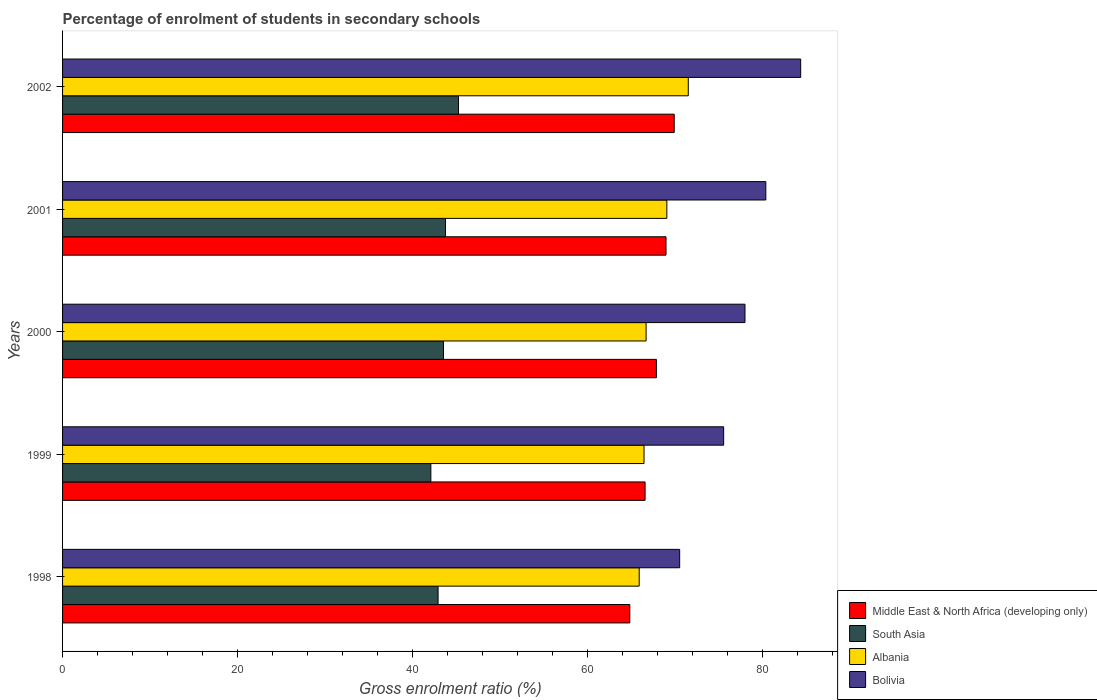How many different coloured bars are there?
Keep it short and to the point. 4. Are the number of bars on each tick of the Y-axis equal?
Provide a short and direct response. Yes. How many bars are there on the 5th tick from the bottom?
Provide a succinct answer. 4. What is the label of the 4th group of bars from the top?
Your answer should be compact. 1999. What is the percentage of students enrolled in secondary schools in South Asia in 2000?
Offer a terse response. 43.53. Across all years, what is the maximum percentage of students enrolled in secondary schools in Bolivia?
Keep it short and to the point. 84.34. Across all years, what is the minimum percentage of students enrolled in secondary schools in South Asia?
Offer a terse response. 42.09. In which year was the percentage of students enrolled in secondary schools in Albania maximum?
Your answer should be very brief. 2002. What is the total percentage of students enrolled in secondary schools in Bolivia in the graph?
Offer a very short reply. 388.74. What is the difference between the percentage of students enrolled in secondary schools in Albania in 2000 and that in 2001?
Your response must be concise. -2.37. What is the difference between the percentage of students enrolled in secondary schools in Bolivia in 2000 and the percentage of students enrolled in secondary schools in Middle East & North Africa (developing only) in 1999?
Give a very brief answer. 11.42. What is the average percentage of students enrolled in secondary schools in Albania per year?
Offer a terse response. 67.91. In the year 2002, what is the difference between the percentage of students enrolled in secondary schools in South Asia and percentage of students enrolled in secondary schools in Middle East & North Africa (developing only)?
Keep it short and to the point. -24.65. What is the ratio of the percentage of students enrolled in secondary schools in Bolivia in 1999 to that in 2001?
Ensure brevity in your answer.  0.94. Is the percentage of students enrolled in secondary schools in Middle East & North Africa (developing only) in 1998 less than that in 1999?
Offer a terse response. Yes. What is the difference between the highest and the second highest percentage of students enrolled in secondary schools in Middle East & North Africa (developing only)?
Provide a short and direct response. 0.94. What is the difference between the highest and the lowest percentage of students enrolled in secondary schools in Middle East & North Africa (developing only)?
Make the answer very short. 5.07. Is it the case that in every year, the sum of the percentage of students enrolled in secondary schools in Middle East & North Africa (developing only) and percentage of students enrolled in secondary schools in Bolivia is greater than the sum of percentage of students enrolled in secondary schools in Albania and percentage of students enrolled in secondary schools in South Asia?
Provide a short and direct response. Yes. What does the 3rd bar from the top in 2000 represents?
Provide a short and direct response. South Asia. What does the 1st bar from the bottom in 2001 represents?
Offer a very short reply. Middle East & North Africa (developing only). How many bars are there?
Give a very brief answer. 20. Are all the bars in the graph horizontal?
Your response must be concise. Yes. What is the difference between two consecutive major ticks on the X-axis?
Offer a very short reply. 20. Does the graph contain any zero values?
Your response must be concise. No. Does the graph contain grids?
Offer a very short reply. No. How many legend labels are there?
Your response must be concise. 4. How are the legend labels stacked?
Provide a succinct answer. Vertical. What is the title of the graph?
Your answer should be compact. Percentage of enrolment of students in secondary schools. Does "Djibouti" appear as one of the legend labels in the graph?
Make the answer very short. No. What is the label or title of the X-axis?
Your answer should be very brief. Gross enrolment ratio (%). What is the label or title of the Y-axis?
Provide a short and direct response. Years. What is the Gross enrolment ratio (%) in Middle East & North Africa (developing only) in 1998?
Your answer should be very brief. 64.82. What is the Gross enrolment ratio (%) in South Asia in 1998?
Your response must be concise. 42.91. What is the Gross enrolment ratio (%) of Albania in 1998?
Ensure brevity in your answer.  65.89. What is the Gross enrolment ratio (%) in Bolivia in 1998?
Ensure brevity in your answer.  70.51. What is the Gross enrolment ratio (%) of Middle East & North Africa (developing only) in 1999?
Offer a terse response. 66.56. What is the Gross enrolment ratio (%) in South Asia in 1999?
Keep it short and to the point. 42.09. What is the Gross enrolment ratio (%) in Albania in 1999?
Provide a short and direct response. 66.44. What is the Gross enrolment ratio (%) in Bolivia in 1999?
Give a very brief answer. 75.54. What is the Gross enrolment ratio (%) in Middle East & North Africa (developing only) in 2000?
Keep it short and to the point. 67.86. What is the Gross enrolment ratio (%) of South Asia in 2000?
Give a very brief answer. 43.53. What is the Gross enrolment ratio (%) in Albania in 2000?
Give a very brief answer. 66.68. What is the Gross enrolment ratio (%) in Bolivia in 2000?
Offer a terse response. 77.98. What is the Gross enrolment ratio (%) in Middle East & North Africa (developing only) in 2001?
Give a very brief answer. 68.96. What is the Gross enrolment ratio (%) in South Asia in 2001?
Provide a succinct answer. 43.76. What is the Gross enrolment ratio (%) of Albania in 2001?
Provide a short and direct response. 69.05. What is the Gross enrolment ratio (%) of Bolivia in 2001?
Your answer should be compact. 80.36. What is the Gross enrolment ratio (%) of Middle East & North Africa (developing only) in 2002?
Provide a short and direct response. 69.89. What is the Gross enrolment ratio (%) of South Asia in 2002?
Provide a succinct answer. 45.24. What is the Gross enrolment ratio (%) of Albania in 2002?
Provide a short and direct response. 71.5. What is the Gross enrolment ratio (%) in Bolivia in 2002?
Offer a terse response. 84.34. Across all years, what is the maximum Gross enrolment ratio (%) in Middle East & North Africa (developing only)?
Give a very brief answer. 69.89. Across all years, what is the maximum Gross enrolment ratio (%) of South Asia?
Ensure brevity in your answer.  45.24. Across all years, what is the maximum Gross enrolment ratio (%) of Albania?
Make the answer very short. 71.5. Across all years, what is the maximum Gross enrolment ratio (%) of Bolivia?
Your answer should be very brief. 84.34. Across all years, what is the minimum Gross enrolment ratio (%) in Middle East & North Africa (developing only)?
Keep it short and to the point. 64.82. Across all years, what is the minimum Gross enrolment ratio (%) in South Asia?
Provide a short and direct response. 42.09. Across all years, what is the minimum Gross enrolment ratio (%) of Albania?
Your response must be concise. 65.89. Across all years, what is the minimum Gross enrolment ratio (%) of Bolivia?
Your response must be concise. 70.51. What is the total Gross enrolment ratio (%) of Middle East & North Africa (developing only) in the graph?
Make the answer very short. 338.09. What is the total Gross enrolment ratio (%) of South Asia in the graph?
Give a very brief answer. 217.52. What is the total Gross enrolment ratio (%) in Albania in the graph?
Your answer should be very brief. 339.56. What is the total Gross enrolment ratio (%) in Bolivia in the graph?
Ensure brevity in your answer.  388.74. What is the difference between the Gross enrolment ratio (%) of Middle East & North Africa (developing only) in 1998 and that in 1999?
Offer a very short reply. -1.74. What is the difference between the Gross enrolment ratio (%) in South Asia in 1998 and that in 1999?
Keep it short and to the point. 0.82. What is the difference between the Gross enrolment ratio (%) in Albania in 1998 and that in 1999?
Your response must be concise. -0.55. What is the difference between the Gross enrolment ratio (%) in Bolivia in 1998 and that in 1999?
Your answer should be compact. -5.03. What is the difference between the Gross enrolment ratio (%) of Middle East & North Africa (developing only) in 1998 and that in 2000?
Your answer should be very brief. -3.04. What is the difference between the Gross enrolment ratio (%) in South Asia in 1998 and that in 2000?
Keep it short and to the point. -0.62. What is the difference between the Gross enrolment ratio (%) in Albania in 1998 and that in 2000?
Offer a terse response. -0.79. What is the difference between the Gross enrolment ratio (%) in Bolivia in 1998 and that in 2000?
Your response must be concise. -7.46. What is the difference between the Gross enrolment ratio (%) in Middle East & North Africa (developing only) in 1998 and that in 2001?
Make the answer very short. -4.14. What is the difference between the Gross enrolment ratio (%) of South Asia in 1998 and that in 2001?
Provide a short and direct response. -0.85. What is the difference between the Gross enrolment ratio (%) of Albania in 1998 and that in 2001?
Provide a short and direct response. -3.16. What is the difference between the Gross enrolment ratio (%) of Bolivia in 1998 and that in 2001?
Offer a terse response. -9.85. What is the difference between the Gross enrolment ratio (%) in Middle East & North Africa (developing only) in 1998 and that in 2002?
Provide a short and direct response. -5.07. What is the difference between the Gross enrolment ratio (%) of South Asia in 1998 and that in 2002?
Provide a succinct answer. -2.33. What is the difference between the Gross enrolment ratio (%) of Albania in 1998 and that in 2002?
Provide a succinct answer. -5.61. What is the difference between the Gross enrolment ratio (%) in Bolivia in 1998 and that in 2002?
Keep it short and to the point. -13.83. What is the difference between the Gross enrolment ratio (%) of Middle East & North Africa (developing only) in 1999 and that in 2000?
Keep it short and to the point. -1.29. What is the difference between the Gross enrolment ratio (%) in South Asia in 1999 and that in 2000?
Ensure brevity in your answer.  -1.44. What is the difference between the Gross enrolment ratio (%) of Albania in 1999 and that in 2000?
Keep it short and to the point. -0.24. What is the difference between the Gross enrolment ratio (%) in Bolivia in 1999 and that in 2000?
Give a very brief answer. -2.44. What is the difference between the Gross enrolment ratio (%) of Middle East & North Africa (developing only) in 1999 and that in 2001?
Your answer should be compact. -2.39. What is the difference between the Gross enrolment ratio (%) of South Asia in 1999 and that in 2001?
Your answer should be compact. -1.67. What is the difference between the Gross enrolment ratio (%) in Albania in 1999 and that in 2001?
Offer a very short reply. -2.61. What is the difference between the Gross enrolment ratio (%) of Bolivia in 1999 and that in 2001?
Your answer should be compact. -4.82. What is the difference between the Gross enrolment ratio (%) in Middle East & North Africa (developing only) in 1999 and that in 2002?
Your answer should be very brief. -3.33. What is the difference between the Gross enrolment ratio (%) in South Asia in 1999 and that in 2002?
Provide a succinct answer. -3.16. What is the difference between the Gross enrolment ratio (%) in Albania in 1999 and that in 2002?
Ensure brevity in your answer.  -5.06. What is the difference between the Gross enrolment ratio (%) of Bolivia in 1999 and that in 2002?
Provide a short and direct response. -8.8. What is the difference between the Gross enrolment ratio (%) of Middle East & North Africa (developing only) in 2000 and that in 2001?
Ensure brevity in your answer.  -1.1. What is the difference between the Gross enrolment ratio (%) in South Asia in 2000 and that in 2001?
Keep it short and to the point. -0.23. What is the difference between the Gross enrolment ratio (%) of Albania in 2000 and that in 2001?
Your response must be concise. -2.37. What is the difference between the Gross enrolment ratio (%) in Bolivia in 2000 and that in 2001?
Ensure brevity in your answer.  -2.38. What is the difference between the Gross enrolment ratio (%) of Middle East & North Africa (developing only) in 2000 and that in 2002?
Make the answer very short. -2.04. What is the difference between the Gross enrolment ratio (%) of South Asia in 2000 and that in 2002?
Make the answer very short. -1.71. What is the difference between the Gross enrolment ratio (%) in Albania in 2000 and that in 2002?
Offer a terse response. -4.82. What is the difference between the Gross enrolment ratio (%) of Bolivia in 2000 and that in 2002?
Keep it short and to the point. -6.37. What is the difference between the Gross enrolment ratio (%) of Middle East & North Africa (developing only) in 2001 and that in 2002?
Offer a very short reply. -0.94. What is the difference between the Gross enrolment ratio (%) of South Asia in 2001 and that in 2002?
Offer a terse response. -1.48. What is the difference between the Gross enrolment ratio (%) in Albania in 2001 and that in 2002?
Provide a short and direct response. -2.45. What is the difference between the Gross enrolment ratio (%) in Bolivia in 2001 and that in 2002?
Your answer should be compact. -3.98. What is the difference between the Gross enrolment ratio (%) of Middle East & North Africa (developing only) in 1998 and the Gross enrolment ratio (%) of South Asia in 1999?
Provide a short and direct response. 22.73. What is the difference between the Gross enrolment ratio (%) in Middle East & North Africa (developing only) in 1998 and the Gross enrolment ratio (%) in Albania in 1999?
Offer a terse response. -1.62. What is the difference between the Gross enrolment ratio (%) in Middle East & North Africa (developing only) in 1998 and the Gross enrolment ratio (%) in Bolivia in 1999?
Make the answer very short. -10.72. What is the difference between the Gross enrolment ratio (%) in South Asia in 1998 and the Gross enrolment ratio (%) in Albania in 1999?
Ensure brevity in your answer.  -23.53. What is the difference between the Gross enrolment ratio (%) of South Asia in 1998 and the Gross enrolment ratio (%) of Bolivia in 1999?
Make the answer very short. -32.63. What is the difference between the Gross enrolment ratio (%) of Albania in 1998 and the Gross enrolment ratio (%) of Bolivia in 1999?
Make the answer very short. -9.65. What is the difference between the Gross enrolment ratio (%) in Middle East & North Africa (developing only) in 1998 and the Gross enrolment ratio (%) in South Asia in 2000?
Keep it short and to the point. 21.29. What is the difference between the Gross enrolment ratio (%) in Middle East & North Africa (developing only) in 1998 and the Gross enrolment ratio (%) in Albania in 2000?
Your answer should be very brief. -1.86. What is the difference between the Gross enrolment ratio (%) in Middle East & North Africa (developing only) in 1998 and the Gross enrolment ratio (%) in Bolivia in 2000?
Give a very brief answer. -13.16. What is the difference between the Gross enrolment ratio (%) in South Asia in 1998 and the Gross enrolment ratio (%) in Albania in 2000?
Your response must be concise. -23.77. What is the difference between the Gross enrolment ratio (%) in South Asia in 1998 and the Gross enrolment ratio (%) in Bolivia in 2000?
Your answer should be very brief. -35.07. What is the difference between the Gross enrolment ratio (%) of Albania in 1998 and the Gross enrolment ratio (%) of Bolivia in 2000?
Offer a very short reply. -12.09. What is the difference between the Gross enrolment ratio (%) in Middle East & North Africa (developing only) in 1998 and the Gross enrolment ratio (%) in South Asia in 2001?
Provide a succinct answer. 21.06. What is the difference between the Gross enrolment ratio (%) in Middle East & North Africa (developing only) in 1998 and the Gross enrolment ratio (%) in Albania in 2001?
Provide a succinct answer. -4.23. What is the difference between the Gross enrolment ratio (%) in Middle East & North Africa (developing only) in 1998 and the Gross enrolment ratio (%) in Bolivia in 2001?
Give a very brief answer. -15.54. What is the difference between the Gross enrolment ratio (%) of South Asia in 1998 and the Gross enrolment ratio (%) of Albania in 2001?
Offer a very short reply. -26.14. What is the difference between the Gross enrolment ratio (%) of South Asia in 1998 and the Gross enrolment ratio (%) of Bolivia in 2001?
Your answer should be very brief. -37.45. What is the difference between the Gross enrolment ratio (%) in Albania in 1998 and the Gross enrolment ratio (%) in Bolivia in 2001?
Offer a terse response. -14.47. What is the difference between the Gross enrolment ratio (%) in Middle East & North Africa (developing only) in 1998 and the Gross enrolment ratio (%) in South Asia in 2002?
Provide a short and direct response. 19.58. What is the difference between the Gross enrolment ratio (%) in Middle East & North Africa (developing only) in 1998 and the Gross enrolment ratio (%) in Albania in 2002?
Make the answer very short. -6.68. What is the difference between the Gross enrolment ratio (%) in Middle East & North Africa (developing only) in 1998 and the Gross enrolment ratio (%) in Bolivia in 2002?
Your answer should be compact. -19.53. What is the difference between the Gross enrolment ratio (%) of South Asia in 1998 and the Gross enrolment ratio (%) of Albania in 2002?
Keep it short and to the point. -28.59. What is the difference between the Gross enrolment ratio (%) in South Asia in 1998 and the Gross enrolment ratio (%) in Bolivia in 2002?
Your answer should be very brief. -41.44. What is the difference between the Gross enrolment ratio (%) of Albania in 1998 and the Gross enrolment ratio (%) of Bolivia in 2002?
Keep it short and to the point. -18.45. What is the difference between the Gross enrolment ratio (%) of Middle East & North Africa (developing only) in 1999 and the Gross enrolment ratio (%) of South Asia in 2000?
Make the answer very short. 23.04. What is the difference between the Gross enrolment ratio (%) of Middle East & North Africa (developing only) in 1999 and the Gross enrolment ratio (%) of Albania in 2000?
Offer a very short reply. -0.12. What is the difference between the Gross enrolment ratio (%) in Middle East & North Africa (developing only) in 1999 and the Gross enrolment ratio (%) in Bolivia in 2000?
Make the answer very short. -11.42. What is the difference between the Gross enrolment ratio (%) in South Asia in 1999 and the Gross enrolment ratio (%) in Albania in 2000?
Your response must be concise. -24.59. What is the difference between the Gross enrolment ratio (%) in South Asia in 1999 and the Gross enrolment ratio (%) in Bolivia in 2000?
Provide a succinct answer. -35.89. What is the difference between the Gross enrolment ratio (%) in Albania in 1999 and the Gross enrolment ratio (%) in Bolivia in 2000?
Ensure brevity in your answer.  -11.54. What is the difference between the Gross enrolment ratio (%) of Middle East & North Africa (developing only) in 1999 and the Gross enrolment ratio (%) of South Asia in 2001?
Provide a short and direct response. 22.8. What is the difference between the Gross enrolment ratio (%) in Middle East & North Africa (developing only) in 1999 and the Gross enrolment ratio (%) in Albania in 2001?
Make the answer very short. -2.49. What is the difference between the Gross enrolment ratio (%) in Middle East & North Africa (developing only) in 1999 and the Gross enrolment ratio (%) in Bolivia in 2001?
Your answer should be compact. -13.8. What is the difference between the Gross enrolment ratio (%) of South Asia in 1999 and the Gross enrolment ratio (%) of Albania in 2001?
Ensure brevity in your answer.  -26.96. What is the difference between the Gross enrolment ratio (%) in South Asia in 1999 and the Gross enrolment ratio (%) in Bolivia in 2001?
Your response must be concise. -38.28. What is the difference between the Gross enrolment ratio (%) in Albania in 1999 and the Gross enrolment ratio (%) in Bolivia in 2001?
Offer a terse response. -13.92. What is the difference between the Gross enrolment ratio (%) in Middle East & North Africa (developing only) in 1999 and the Gross enrolment ratio (%) in South Asia in 2002?
Provide a short and direct response. 21.32. What is the difference between the Gross enrolment ratio (%) of Middle East & North Africa (developing only) in 1999 and the Gross enrolment ratio (%) of Albania in 2002?
Your answer should be very brief. -4.94. What is the difference between the Gross enrolment ratio (%) in Middle East & North Africa (developing only) in 1999 and the Gross enrolment ratio (%) in Bolivia in 2002?
Your answer should be very brief. -17.78. What is the difference between the Gross enrolment ratio (%) of South Asia in 1999 and the Gross enrolment ratio (%) of Albania in 2002?
Make the answer very short. -29.41. What is the difference between the Gross enrolment ratio (%) in South Asia in 1999 and the Gross enrolment ratio (%) in Bolivia in 2002?
Keep it short and to the point. -42.26. What is the difference between the Gross enrolment ratio (%) of Albania in 1999 and the Gross enrolment ratio (%) of Bolivia in 2002?
Offer a very short reply. -17.9. What is the difference between the Gross enrolment ratio (%) in Middle East & North Africa (developing only) in 2000 and the Gross enrolment ratio (%) in South Asia in 2001?
Ensure brevity in your answer.  24.1. What is the difference between the Gross enrolment ratio (%) in Middle East & North Africa (developing only) in 2000 and the Gross enrolment ratio (%) in Albania in 2001?
Offer a very short reply. -1.19. What is the difference between the Gross enrolment ratio (%) of Middle East & North Africa (developing only) in 2000 and the Gross enrolment ratio (%) of Bolivia in 2001?
Make the answer very short. -12.5. What is the difference between the Gross enrolment ratio (%) of South Asia in 2000 and the Gross enrolment ratio (%) of Albania in 2001?
Offer a very short reply. -25.52. What is the difference between the Gross enrolment ratio (%) in South Asia in 2000 and the Gross enrolment ratio (%) in Bolivia in 2001?
Make the answer very short. -36.83. What is the difference between the Gross enrolment ratio (%) of Albania in 2000 and the Gross enrolment ratio (%) of Bolivia in 2001?
Your answer should be very brief. -13.68. What is the difference between the Gross enrolment ratio (%) of Middle East & North Africa (developing only) in 2000 and the Gross enrolment ratio (%) of South Asia in 2002?
Provide a short and direct response. 22.61. What is the difference between the Gross enrolment ratio (%) in Middle East & North Africa (developing only) in 2000 and the Gross enrolment ratio (%) in Albania in 2002?
Offer a terse response. -3.64. What is the difference between the Gross enrolment ratio (%) of Middle East & North Africa (developing only) in 2000 and the Gross enrolment ratio (%) of Bolivia in 2002?
Offer a terse response. -16.49. What is the difference between the Gross enrolment ratio (%) in South Asia in 2000 and the Gross enrolment ratio (%) in Albania in 2002?
Make the answer very short. -27.97. What is the difference between the Gross enrolment ratio (%) in South Asia in 2000 and the Gross enrolment ratio (%) in Bolivia in 2002?
Make the answer very short. -40.82. What is the difference between the Gross enrolment ratio (%) in Albania in 2000 and the Gross enrolment ratio (%) in Bolivia in 2002?
Make the answer very short. -17.67. What is the difference between the Gross enrolment ratio (%) in Middle East & North Africa (developing only) in 2001 and the Gross enrolment ratio (%) in South Asia in 2002?
Your answer should be compact. 23.71. What is the difference between the Gross enrolment ratio (%) of Middle East & North Africa (developing only) in 2001 and the Gross enrolment ratio (%) of Albania in 2002?
Make the answer very short. -2.54. What is the difference between the Gross enrolment ratio (%) in Middle East & North Africa (developing only) in 2001 and the Gross enrolment ratio (%) in Bolivia in 2002?
Offer a very short reply. -15.39. What is the difference between the Gross enrolment ratio (%) in South Asia in 2001 and the Gross enrolment ratio (%) in Albania in 2002?
Make the answer very short. -27.74. What is the difference between the Gross enrolment ratio (%) in South Asia in 2001 and the Gross enrolment ratio (%) in Bolivia in 2002?
Provide a short and direct response. -40.59. What is the difference between the Gross enrolment ratio (%) of Albania in 2001 and the Gross enrolment ratio (%) of Bolivia in 2002?
Your answer should be very brief. -15.29. What is the average Gross enrolment ratio (%) of Middle East & North Africa (developing only) per year?
Your response must be concise. 67.62. What is the average Gross enrolment ratio (%) in South Asia per year?
Ensure brevity in your answer.  43.5. What is the average Gross enrolment ratio (%) of Albania per year?
Ensure brevity in your answer.  67.91. What is the average Gross enrolment ratio (%) in Bolivia per year?
Provide a short and direct response. 77.75. In the year 1998, what is the difference between the Gross enrolment ratio (%) of Middle East & North Africa (developing only) and Gross enrolment ratio (%) of South Asia?
Provide a short and direct response. 21.91. In the year 1998, what is the difference between the Gross enrolment ratio (%) of Middle East & North Africa (developing only) and Gross enrolment ratio (%) of Albania?
Give a very brief answer. -1.07. In the year 1998, what is the difference between the Gross enrolment ratio (%) in Middle East & North Africa (developing only) and Gross enrolment ratio (%) in Bolivia?
Give a very brief answer. -5.7. In the year 1998, what is the difference between the Gross enrolment ratio (%) of South Asia and Gross enrolment ratio (%) of Albania?
Ensure brevity in your answer.  -22.98. In the year 1998, what is the difference between the Gross enrolment ratio (%) of South Asia and Gross enrolment ratio (%) of Bolivia?
Keep it short and to the point. -27.61. In the year 1998, what is the difference between the Gross enrolment ratio (%) in Albania and Gross enrolment ratio (%) in Bolivia?
Offer a very short reply. -4.62. In the year 1999, what is the difference between the Gross enrolment ratio (%) of Middle East & North Africa (developing only) and Gross enrolment ratio (%) of South Asia?
Your answer should be compact. 24.48. In the year 1999, what is the difference between the Gross enrolment ratio (%) in Middle East & North Africa (developing only) and Gross enrolment ratio (%) in Albania?
Give a very brief answer. 0.12. In the year 1999, what is the difference between the Gross enrolment ratio (%) of Middle East & North Africa (developing only) and Gross enrolment ratio (%) of Bolivia?
Provide a short and direct response. -8.98. In the year 1999, what is the difference between the Gross enrolment ratio (%) in South Asia and Gross enrolment ratio (%) in Albania?
Your answer should be very brief. -24.36. In the year 1999, what is the difference between the Gross enrolment ratio (%) in South Asia and Gross enrolment ratio (%) in Bolivia?
Provide a short and direct response. -33.46. In the year 1999, what is the difference between the Gross enrolment ratio (%) of Albania and Gross enrolment ratio (%) of Bolivia?
Your answer should be compact. -9.1. In the year 2000, what is the difference between the Gross enrolment ratio (%) of Middle East & North Africa (developing only) and Gross enrolment ratio (%) of South Asia?
Your answer should be compact. 24.33. In the year 2000, what is the difference between the Gross enrolment ratio (%) of Middle East & North Africa (developing only) and Gross enrolment ratio (%) of Albania?
Offer a very short reply. 1.18. In the year 2000, what is the difference between the Gross enrolment ratio (%) in Middle East & North Africa (developing only) and Gross enrolment ratio (%) in Bolivia?
Provide a succinct answer. -10.12. In the year 2000, what is the difference between the Gross enrolment ratio (%) in South Asia and Gross enrolment ratio (%) in Albania?
Your answer should be compact. -23.15. In the year 2000, what is the difference between the Gross enrolment ratio (%) in South Asia and Gross enrolment ratio (%) in Bolivia?
Your answer should be very brief. -34.45. In the year 2000, what is the difference between the Gross enrolment ratio (%) in Albania and Gross enrolment ratio (%) in Bolivia?
Make the answer very short. -11.3. In the year 2001, what is the difference between the Gross enrolment ratio (%) in Middle East & North Africa (developing only) and Gross enrolment ratio (%) in South Asia?
Your answer should be compact. 25.2. In the year 2001, what is the difference between the Gross enrolment ratio (%) in Middle East & North Africa (developing only) and Gross enrolment ratio (%) in Albania?
Give a very brief answer. -0.09. In the year 2001, what is the difference between the Gross enrolment ratio (%) of Middle East & North Africa (developing only) and Gross enrolment ratio (%) of Bolivia?
Your response must be concise. -11.41. In the year 2001, what is the difference between the Gross enrolment ratio (%) in South Asia and Gross enrolment ratio (%) in Albania?
Ensure brevity in your answer.  -25.29. In the year 2001, what is the difference between the Gross enrolment ratio (%) in South Asia and Gross enrolment ratio (%) in Bolivia?
Ensure brevity in your answer.  -36.6. In the year 2001, what is the difference between the Gross enrolment ratio (%) in Albania and Gross enrolment ratio (%) in Bolivia?
Offer a terse response. -11.31. In the year 2002, what is the difference between the Gross enrolment ratio (%) of Middle East & North Africa (developing only) and Gross enrolment ratio (%) of South Asia?
Keep it short and to the point. 24.65. In the year 2002, what is the difference between the Gross enrolment ratio (%) in Middle East & North Africa (developing only) and Gross enrolment ratio (%) in Albania?
Your answer should be compact. -1.61. In the year 2002, what is the difference between the Gross enrolment ratio (%) in Middle East & North Africa (developing only) and Gross enrolment ratio (%) in Bolivia?
Provide a succinct answer. -14.45. In the year 2002, what is the difference between the Gross enrolment ratio (%) in South Asia and Gross enrolment ratio (%) in Albania?
Ensure brevity in your answer.  -26.26. In the year 2002, what is the difference between the Gross enrolment ratio (%) in South Asia and Gross enrolment ratio (%) in Bolivia?
Make the answer very short. -39.1. In the year 2002, what is the difference between the Gross enrolment ratio (%) in Albania and Gross enrolment ratio (%) in Bolivia?
Your response must be concise. -12.85. What is the ratio of the Gross enrolment ratio (%) of Middle East & North Africa (developing only) in 1998 to that in 1999?
Your answer should be compact. 0.97. What is the ratio of the Gross enrolment ratio (%) of South Asia in 1998 to that in 1999?
Offer a terse response. 1.02. What is the ratio of the Gross enrolment ratio (%) in Albania in 1998 to that in 1999?
Offer a very short reply. 0.99. What is the ratio of the Gross enrolment ratio (%) in Bolivia in 1998 to that in 1999?
Offer a terse response. 0.93. What is the ratio of the Gross enrolment ratio (%) of Middle East & North Africa (developing only) in 1998 to that in 2000?
Give a very brief answer. 0.96. What is the ratio of the Gross enrolment ratio (%) of South Asia in 1998 to that in 2000?
Offer a terse response. 0.99. What is the ratio of the Gross enrolment ratio (%) in Bolivia in 1998 to that in 2000?
Ensure brevity in your answer.  0.9. What is the ratio of the Gross enrolment ratio (%) of South Asia in 1998 to that in 2001?
Your answer should be very brief. 0.98. What is the ratio of the Gross enrolment ratio (%) of Albania in 1998 to that in 2001?
Your response must be concise. 0.95. What is the ratio of the Gross enrolment ratio (%) of Bolivia in 1998 to that in 2001?
Ensure brevity in your answer.  0.88. What is the ratio of the Gross enrolment ratio (%) in Middle East & North Africa (developing only) in 1998 to that in 2002?
Your answer should be compact. 0.93. What is the ratio of the Gross enrolment ratio (%) in South Asia in 1998 to that in 2002?
Your answer should be compact. 0.95. What is the ratio of the Gross enrolment ratio (%) of Albania in 1998 to that in 2002?
Offer a terse response. 0.92. What is the ratio of the Gross enrolment ratio (%) of Bolivia in 1998 to that in 2002?
Offer a very short reply. 0.84. What is the ratio of the Gross enrolment ratio (%) in Middle East & North Africa (developing only) in 1999 to that in 2000?
Keep it short and to the point. 0.98. What is the ratio of the Gross enrolment ratio (%) of South Asia in 1999 to that in 2000?
Make the answer very short. 0.97. What is the ratio of the Gross enrolment ratio (%) of Bolivia in 1999 to that in 2000?
Offer a very short reply. 0.97. What is the ratio of the Gross enrolment ratio (%) in Middle East & North Africa (developing only) in 1999 to that in 2001?
Provide a short and direct response. 0.97. What is the ratio of the Gross enrolment ratio (%) in South Asia in 1999 to that in 2001?
Your answer should be very brief. 0.96. What is the ratio of the Gross enrolment ratio (%) in Albania in 1999 to that in 2001?
Ensure brevity in your answer.  0.96. What is the ratio of the Gross enrolment ratio (%) of Bolivia in 1999 to that in 2001?
Make the answer very short. 0.94. What is the ratio of the Gross enrolment ratio (%) in Middle East & North Africa (developing only) in 1999 to that in 2002?
Provide a succinct answer. 0.95. What is the ratio of the Gross enrolment ratio (%) in South Asia in 1999 to that in 2002?
Keep it short and to the point. 0.93. What is the ratio of the Gross enrolment ratio (%) in Albania in 1999 to that in 2002?
Your answer should be compact. 0.93. What is the ratio of the Gross enrolment ratio (%) of Bolivia in 1999 to that in 2002?
Give a very brief answer. 0.9. What is the ratio of the Gross enrolment ratio (%) in Middle East & North Africa (developing only) in 2000 to that in 2001?
Provide a short and direct response. 0.98. What is the ratio of the Gross enrolment ratio (%) of Albania in 2000 to that in 2001?
Give a very brief answer. 0.97. What is the ratio of the Gross enrolment ratio (%) of Bolivia in 2000 to that in 2001?
Offer a terse response. 0.97. What is the ratio of the Gross enrolment ratio (%) of Middle East & North Africa (developing only) in 2000 to that in 2002?
Make the answer very short. 0.97. What is the ratio of the Gross enrolment ratio (%) of South Asia in 2000 to that in 2002?
Your answer should be very brief. 0.96. What is the ratio of the Gross enrolment ratio (%) of Albania in 2000 to that in 2002?
Make the answer very short. 0.93. What is the ratio of the Gross enrolment ratio (%) in Bolivia in 2000 to that in 2002?
Keep it short and to the point. 0.92. What is the ratio of the Gross enrolment ratio (%) in Middle East & North Africa (developing only) in 2001 to that in 2002?
Provide a short and direct response. 0.99. What is the ratio of the Gross enrolment ratio (%) in South Asia in 2001 to that in 2002?
Provide a succinct answer. 0.97. What is the ratio of the Gross enrolment ratio (%) of Albania in 2001 to that in 2002?
Provide a succinct answer. 0.97. What is the ratio of the Gross enrolment ratio (%) of Bolivia in 2001 to that in 2002?
Keep it short and to the point. 0.95. What is the difference between the highest and the second highest Gross enrolment ratio (%) of Middle East & North Africa (developing only)?
Offer a very short reply. 0.94. What is the difference between the highest and the second highest Gross enrolment ratio (%) of South Asia?
Your answer should be compact. 1.48. What is the difference between the highest and the second highest Gross enrolment ratio (%) in Albania?
Your response must be concise. 2.45. What is the difference between the highest and the second highest Gross enrolment ratio (%) in Bolivia?
Provide a short and direct response. 3.98. What is the difference between the highest and the lowest Gross enrolment ratio (%) in Middle East & North Africa (developing only)?
Provide a short and direct response. 5.07. What is the difference between the highest and the lowest Gross enrolment ratio (%) in South Asia?
Offer a very short reply. 3.16. What is the difference between the highest and the lowest Gross enrolment ratio (%) of Albania?
Your response must be concise. 5.61. What is the difference between the highest and the lowest Gross enrolment ratio (%) of Bolivia?
Provide a short and direct response. 13.83. 